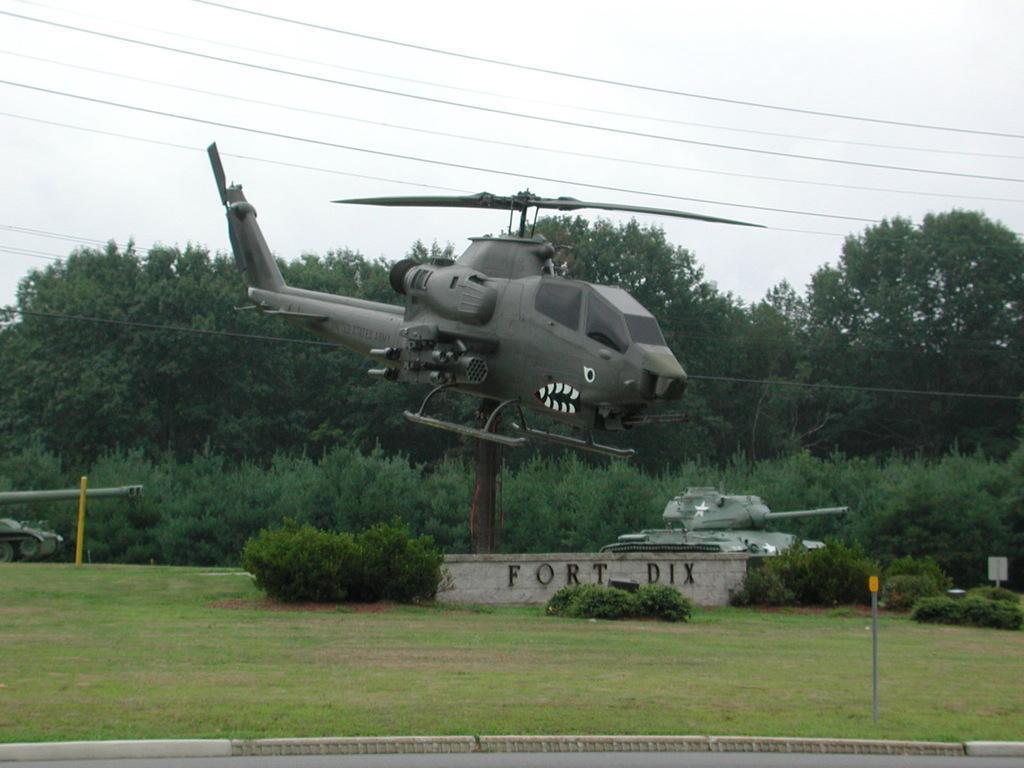Please provide a concise description of this image. There is a grassy land and some plants are present at the bottom of this image. There is an army tanker on the left side of this image and there are some trees in the background. There is a helicopter in the middle of this image, and there is a sky at the top of this image. 